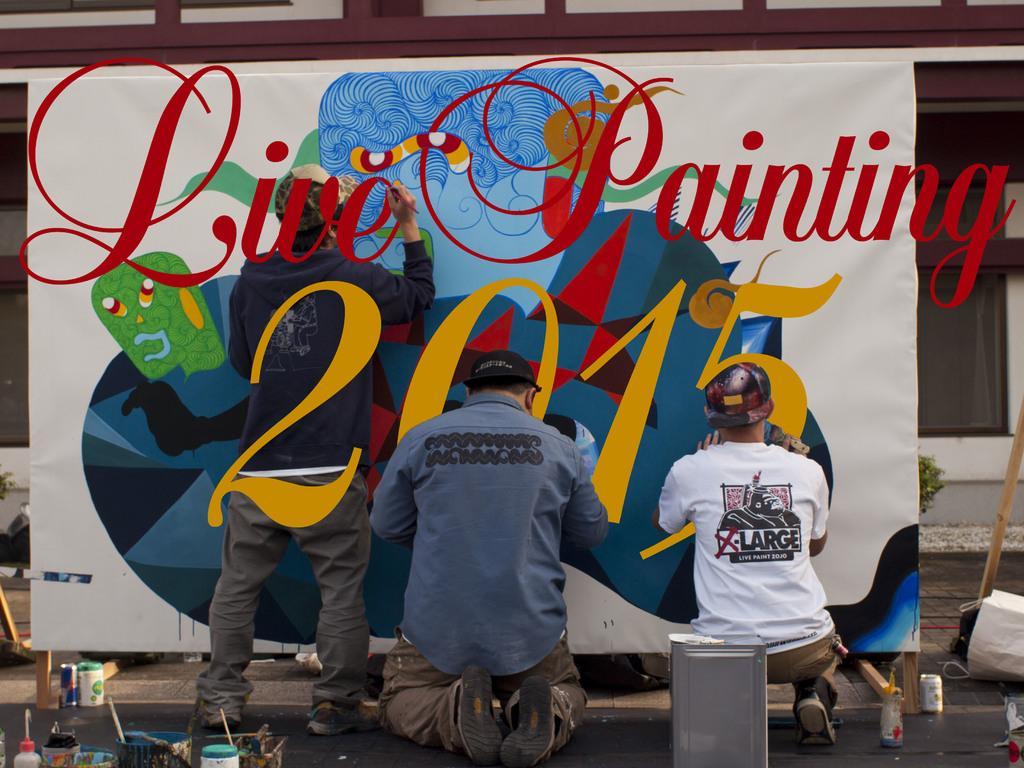Describe this image in one or two sentences. In this image I can see 3 people painting. There are paints, container and other objects in the front. There is a building at the back. 